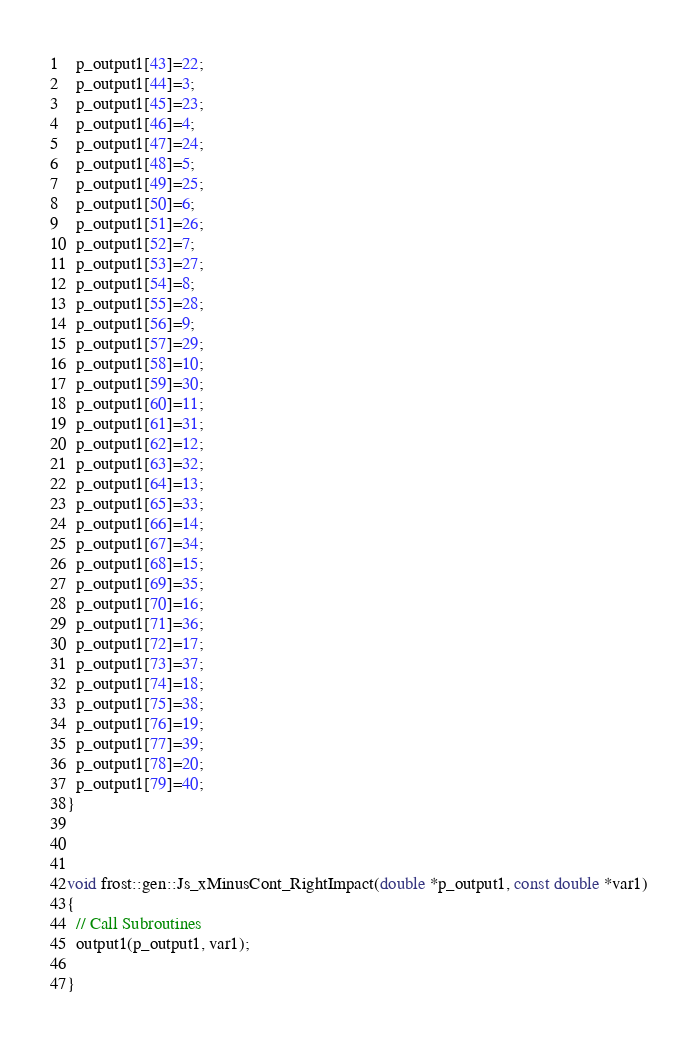<code> <loc_0><loc_0><loc_500><loc_500><_C++_>  p_output1[43]=22;
  p_output1[44]=3;
  p_output1[45]=23;
  p_output1[46]=4;
  p_output1[47]=24;
  p_output1[48]=5;
  p_output1[49]=25;
  p_output1[50]=6;
  p_output1[51]=26;
  p_output1[52]=7;
  p_output1[53]=27;
  p_output1[54]=8;
  p_output1[55]=28;
  p_output1[56]=9;
  p_output1[57]=29;
  p_output1[58]=10;
  p_output1[59]=30;
  p_output1[60]=11;
  p_output1[61]=31;
  p_output1[62]=12;
  p_output1[63]=32;
  p_output1[64]=13;
  p_output1[65]=33;
  p_output1[66]=14;
  p_output1[67]=34;
  p_output1[68]=15;
  p_output1[69]=35;
  p_output1[70]=16;
  p_output1[71]=36;
  p_output1[72]=17;
  p_output1[73]=37;
  p_output1[74]=18;
  p_output1[75]=38;
  p_output1[76]=19;
  p_output1[77]=39;
  p_output1[78]=20;
  p_output1[79]=40;
}



void frost::gen::Js_xMinusCont_RightImpact(double *p_output1, const double *var1)
{
  // Call Subroutines
  output1(p_output1, var1);

}
</code> 